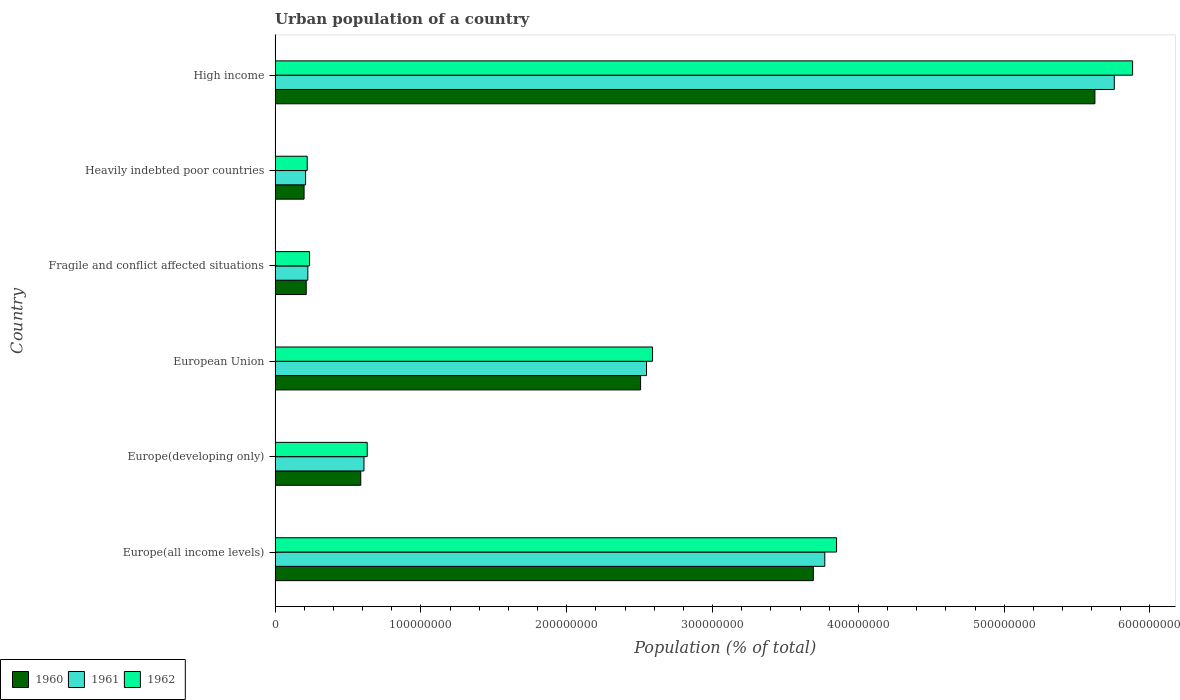Are the number of bars on each tick of the Y-axis equal?
Offer a very short reply. Yes. How many bars are there on the 1st tick from the top?
Offer a very short reply. 3. What is the label of the 1st group of bars from the top?
Your answer should be compact. High income. What is the urban population in 1962 in High income?
Provide a short and direct response. 5.88e+08. Across all countries, what is the maximum urban population in 1960?
Provide a succinct answer. 5.62e+08. Across all countries, what is the minimum urban population in 1961?
Make the answer very short. 2.09e+07. In which country was the urban population in 1962 minimum?
Your response must be concise. Heavily indebted poor countries. What is the total urban population in 1962 in the graph?
Your answer should be very brief. 1.34e+09. What is the difference between the urban population in 1962 in Europe(all income levels) and that in Heavily indebted poor countries?
Make the answer very short. 3.63e+08. What is the difference between the urban population in 1961 in Heavily indebted poor countries and the urban population in 1960 in Fragile and conflict affected situations?
Provide a short and direct response. -4.34e+05. What is the average urban population in 1962 per country?
Your response must be concise. 2.23e+08. What is the difference between the urban population in 1962 and urban population in 1960 in Fragile and conflict affected situations?
Offer a terse response. 2.27e+06. In how many countries, is the urban population in 1961 greater than 580000000 %?
Give a very brief answer. 0. What is the ratio of the urban population in 1960 in Europe(all income levels) to that in Fragile and conflict affected situations?
Ensure brevity in your answer.  17.28. What is the difference between the highest and the second highest urban population in 1960?
Provide a short and direct response. 1.93e+08. What is the difference between the highest and the lowest urban population in 1961?
Provide a succinct answer. 5.55e+08. In how many countries, is the urban population in 1962 greater than the average urban population in 1962 taken over all countries?
Give a very brief answer. 3. What does the 3rd bar from the top in Fragile and conflict affected situations represents?
Provide a succinct answer. 1960. What does the 3rd bar from the bottom in Europe(developing only) represents?
Your answer should be compact. 1962. Is it the case that in every country, the sum of the urban population in 1961 and urban population in 1960 is greater than the urban population in 1962?
Offer a terse response. Yes. How many countries are there in the graph?
Keep it short and to the point. 6. What is the difference between two consecutive major ticks on the X-axis?
Keep it short and to the point. 1.00e+08. Does the graph contain grids?
Offer a terse response. No. How many legend labels are there?
Provide a short and direct response. 3. How are the legend labels stacked?
Offer a very short reply. Horizontal. What is the title of the graph?
Your response must be concise. Urban population of a country. Does "1960" appear as one of the legend labels in the graph?
Offer a very short reply. Yes. What is the label or title of the X-axis?
Your answer should be compact. Population (% of total). What is the label or title of the Y-axis?
Your answer should be compact. Country. What is the Population (% of total) in 1960 in Europe(all income levels)?
Offer a very short reply. 3.69e+08. What is the Population (% of total) in 1961 in Europe(all income levels)?
Give a very brief answer. 3.77e+08. What is the Population (% of total) of 1962 in Europe(all income levels)?
Your answer should be compact. 3.85e+08. What is the Population (% of total) in 1960 in Europe(developing only)?
Your answer should be compact. 5.88e+07. What is the Population (% of total) of 1961 in Europe(developing only)?
Your answer should be compact. 6.10e+07. What is the Population (% of total) in 1962 in Europe(developing only)?
Make the answer very short. 6.32e+07. What is the Population (% of total) of 1960 in European Union?
Your answer should be very brief. 2.51e+08. What is the Population (% of total) of 1961 in European Union?
Ensure brevity in your answer.  2.55e+08. What is the Population (% of total) of 1962 in European Union?
Offer a very short reply. 2.59e+08. What is the Population (% of total) in 1960 in Fragile and conflict affected situations?
Make the answer very short. 2.14e+07. What is the Population (% of total) of 1961 in Fragile and conflict affected situations?
Provide a succinct answer. 2.25e+07. What is the Population (% of total) of 1962 in Fragile and conflict affected situations?
Ensure brevity in your answer.  2.36e+07. What is the Population (% of total) of 1960 in Heavily indebted poor countries?
Offer a very short reply. 1.99e+07. What is the Population (% of total) of 1961 in Heavily indebted poor countries?
Your answer should be compact. 2.09e+07. What is the Population (% of total) in 1962 in Heavily indebted poor countries?
Offer a terse response. 2.20e+07. What is the Population (% of total) of 1960 in High income?
Ensure brevity in your answer.  5.62e+08. What is the Population (% of total) of 1961 in High income?
Ensure brevity in your answer.  5.76e+08. What is the Population (% of total) in 1962 in High income?
Provide a short and direct response. 5.88e+08. Across all countries, what is the maximum Population (% of total) of 1960?
Provide a succinct answer. 5.62e+08. Across all countries, what is the maximum Population (% of total) of 1961?
Provide a short and direct response. 5.76e+08. Across all countries, what is the maximum Population (% of total) of 1962?
Ensure brevity in your answer.  5.88e+08. Across all countries, what is the minimum Population (% of total) of 1960?
Ensure brevity in your answer.  1.99e+07. Across all countries, what is the minimum Population (% of total) of 1961?
Ensure brevity in your answer.  2.09e+07. Across all countries, what is the minimum Population (% of total) in 1962?
Make the answer very short. 2.20e+07. What is the total Population (% of total) in 1960 in the graph?
Offer a very short reply. 1.28e+09. What is the total Population (% of total) of 1961 in the graph?
Give a very brief answer. 1.31e+09. What is the total Population (% of total) in 1962 in the graph?
Your answer should be compact. 1.34e+09. What is the difference between the Population (% of total) in 1960 in Europe(all income levels) and that in Europe(developing only)?
Ensure brevity in your answer.  3.10e+08. What is the difference between the Population (% of total) in 1961 in Europe(all income levels) and that in Europe(developing only)?
Offer a very short reply. 3.16e+08. What is the difference between the Population (% of total) in 1962 in Europe(all income levels) and that in Europe(developing only)?
Your answer should be very brief. 3.22e+08. What is the difference between the Population (% of total) in 1960 in Europe(all income levels) and that in European Union?
Provide a short and direct response. 1.18e+08. What is the difference between the Population (% of total) in 1961 in Europe(all income levels) and that in European Union?
Offer a very short reply. 1.22e+08. What is the difference between the Population (% of total) in 1962 in Europe(all income levels) and that in European Union?
Offer a very short reply. 1.26e+08. What is the difference between the Population (% of total) of 1960 in Europe(all income levels) and that in Fragile and conflict affected situations?
Keep it short and to the point. 3.48e+08. What is the difference between the Population (% of total) of 1961 in Europe(all income levels) and that in Fragile and conflict affected situations?
Your answer should be compact. 3.55e+08. What is the difference between the Population (% of total) of 1962 in Europe(all income levels) and that in Fragile and conflict affected situations?
Offer a very short reply. 3.61e+08. What is the difference between the Population (% of total) in 1960 in Europe(all income levels) and that in Heavily indebted poor countries?
Ensure brevity in your answer.  3.49e+08. What is the difference between the Population (% of total) in 1961 in Europe(all income levels) and that in Heavily indebted poor countries?
Your response must be concise. 3.56e+08. What is the difference between the Population (% of total) in 1962 in Europe(all income levels) and that in Heavily indebted poor countries?
Offer a terse response. 3.63e+08. What is the difference between the Population (% of total) in 1960 in Europe(all income levels) and that in High income?
Your answer should be very brief. -1.93e+08. What is the difference between the Population (% of total) in 1961 in Europe(all income levels) and that in High income?
Provide a short and direct response. -1.99e+08. What is the difference between the Population (% of total) in 1962 in Europe(all income levels) and that in High income?
Offer a very short reply. -2.03e+08. What is the difference between the Population (% of total) in 1960 in Europe(developing only) and that in European Union?
Your answer should be very brief. -1.92e+08. What is the difference between the Population (% of total) in 1961 in Europe(developing only) and that in European Union?
Your response must be concise. -1.94e+08. What is the difference between the Population (% of total) of 1962 in Europe(developing only) and that in European Union?
Your answer should be very brief. -1.96e+08. What is the difference between the Population (% of total) in 1960 in Europe(developing only) and that in Fragile and conflict affected situations?
Your answer should be very brief. 3.74e+07. What is the difference between the Population (% of total) of 1961 in Europe(developing only) and that in Fragile and conflict affected situations?
Ensure brevity in your answer.  3.85e+07. What is the difference between the Population (% of total) of 1962 in Europe(developing only) and that in Fragile and conflict affected situations?
Provide a succinct answer. 3.96e+07. What is the difference between the Population (% of total) in 1960 in Europe(developing only) and that in Heavily indebted poor countries?
Make the answer very short. 3.89e+07. What is the difference between the Population (% of total) in 1961 in Europe(developing only) and that in Heavily indebted poor countries?
Your answer should be compact. 4.00e+07. What is the difference between the Population (% of total) in 1962 in Europe(developing only) and that in Heavily indebted poor countries?
Keep it short and to the point. 4.11e+07. What is the difference between the Population (% of total) in 1960 in Europe(developing only) and that in High income?
Keep it short and to the point. -5.03e+08. What is the difference between the Population (% of total) of 1961 in Europe(developing only) and that in High income?
Offer a very short reply. -5.15e+08. What is the difference between the Population (% of total) of 1962 in Europe(developing only) and that in High income?
Ensure brevity in your answer.  -5.25e+08. What is the difference between the Population (% of total) in 1960 in European Union and that in Fragile and conflict affected situations?
Your response must be concise. 2.29e+08. What is the difference between the Population (% of total) in 1961 in European Union and that in Fragile and conflict affected situations?
Offer a terse response. 2.32e+08. What is the difference between the Population (% of total) in 1962 in European Union and that in Fragile and conflict affected situations?
Ensure brevity in your answer.  2.35e+08. What is the difference between the Population (% of total) of 1960 in European Union and that in Heavily indebted poor countries?
Ensure brevity in your answer.  2.31e+08. What is the difference between the Population (% of total) of 1961 in European Union and that in Heavily indebted poor countries?
Give a very brief answer. 2.34e+08. What is the difference between the Population (% of total) in 1962 in European Union and that in Heavily indebted poor countries?
Your answer should be very brief. 2.37e+08. What is the difference between the Population (% of total) in 1960 in European Union and that in High income?
Your answer should be very brief. -3.12e+08. What is the difference between the Population (% of total) in 1961 in European Union and that in High income?
Provide a succinct answer. -3.21e+08. What is the difference between the Population (% of total) in 1962 in European Union and that in High income?
Offer a very short reply. -3.29e+08. What is the difference between the Population (% of total) of 1960 in Fragile and conflict affected situations and that in Heavily indebted poor countries?
Your answer should be very brief. 1.48e+06. What is the difference between the Population (% of total) in 1961 in Fragile and conflict affected situations and that in Heavily indebted poor countries?
Your response must be concise. 1.53e+06. What is the difference between the Population (% of total) of 1962 in Fragile and conflict affected situations and that in Heavily indebted poor countries?
Ensure brevity in your answer.  1.59e+06. What is the difference between the Population (% of total) of 1960 in Fragile and conflict affected situations and that in High income?
Keep it short and to the point. -5.41e+08. What is the difference between the Population (% of total) in 1961 in Fragile and conflict affected situations and that in High income?
Ensure brevity in your answer.  -5.53e+08. What is the difference between the Population (% of total) of 1962 in Fragile and conflict affected situations and that in High income?
Make the answer very short. -5.64e+08. What is the difference between the Population (% of total) of 1960 in Heavily indebted poor countries and that in High income?
Offer a terse response. -5.42e+08. What is the difference between the Population (% of total) of 1961 in Heavily indebted poor countries and that in High income?
Make the answer very short. -5.55e+08. What is the difference between the Population (% of total) of 1962 in Heavily indebted poor countries and that in High income?
Keep it short and to the point. -5.66e+08. What is the difference between the Population (% of total) in 1960 in Europe(all income levels) and the Population (% of total) in 1961 in Europe(developing only)?
Provide a short and direct response. 3.08e+08. What is the difference between the Population (% of total) of 1960 in Europe(all income levels) and the Population (% of total) of 1962 in Europe(developing only)?
Your answer should be very brief. 3.06e+08. What is the difference between the Population (% of total) in 1961 in Europe(all income levels) and the Population (% of total) in 1962 in Europe(developing only)?
Provide a succinct answer. 3.14e+08. What is the difference between the Population (% of total) in 1960 in Europe(all income levels) and the Population (% of total) in 1961 in European Union?
Your answer should be compact. 1.14e+08. What is the difference between the Population (% of total) in 1960 in Europe(all income levels) and the Population (% of total) in 1962 in European Union?
Keep it short and to the point. 1.10e+08. What is the difference between the Population (% of total) in 1961 in Europe(all income levels) and the Population (% of total) in 1962 in European Union?
Offer a terse response. 1.18e+08. What is the difference between the Population (% of total) in 1960 in Europe(all income levels) and the Population (% of total) in 1961 in Fragile and conflict affected situations?
Make the answer very short. 3.47e+08. What is the difference between the Population (% of total) of 1960 in Europe(all income levels) and the Population (% of total) of 1962 in Fragile and conflict affected situations?
Give a very brief answer. 3.45e+08. What is the difference between the Population (% of total) of 1961 in Europe(all income levels) and the Population (% of total) of 1962 in Fragile and conflict affected situations?
Keep it short and to the point. 3.53e+08. What is the difference between the Population (% of total) of 1960 in Europe(all income levels) and the Population (% of total) of 1961 in Heavily indebted poor countries?
Your response must be concise. 3.48e+08. What is the difference between the Population (% of total) in 1960 in Europe(all income levels) and the Population (% of total) in 1962 in Heavily indebted poor countries?
Ensure brevity in your answer.  3.47e+08. What is the difference between the Population (% of total) of 1961 in Europe(all income levels) and the Population (% of total) of 1962 in Heavily indebted poor countries?
Your answer should be compact. 3.55e+08. What is the difference between the Population (% of total) of 1960 in Europe(all income levels) and the Population (% of total) of 1961 in High income?
Your answer should be very brief. -2.06e+08. What is the difference between the Population (% of total) in 1960 in Europe(all income levels) and the Population (% of total) in 1962 in High income?
Offer a very short reply. -2.19e+08. What is the difference between the Population (% of total) of 1961 in Europe(all income levels) and the Population (% of total) of 1962 in High income?
Ensure brevity in your answer.  -2.11e+08. What is the difference between the Population (% of total) of 1960 in Europe(developing only) and the Population (% of total) of 1961 in European Union?
Offer a terse response. -1.96e+08. What is the difference between the Population (% of total) of 1960 in Europe(developing only) and the Population (% of total) of 1962 in European Union?
Your answer should be compact. -2.00e+08. What is the difference between the Population (% of total) of 1961 in Europe(developing only) and the Population (% of total) of 1962 in European Union?
Your answer should be very brief. -1.98e+08. What is the difference between the Population (% of total) in 1960 in Europe(developing only) and the Population (% of total) in 1961 in Fragile and conflict affected situations?
Give a very brief answer. 3.63e+07. What is the difference between the Population (% of total) of 1960 in Europe(developing only) and the Population (% of total) of 1962 in Fragile and conflict affected situations?
Keep it short and to the point. 3.51e+07. What is the difference between the Population (% of total) of 1961 in Europe(developing only) and the Population (% of total) of 1962 in Fragile and conflict affected situations?
Ensure brevity in your answer.  3.73e+07. What is the difference between the Population (% of total) in 1960 in Europe(developing only) and the Population (% of total) in 1961 in Heavily indebted poor countries?
Give a very brief answer. 3.78e+07. What is the difference between the Population (% of total) of 1960 in Europe(developing only) and the Population (% of total) of 1962 in Heavily indebted poor countries?
Your answer should be very brief. 3.67e+07. What is the difference between the Population (% of total) in 1961 in Europe(developing only) and the Population (% of total) in 1962 in Heavily indebted poor countries?
Provide a short and direct response. 3.89e+07. What is the difference between the Population (% of total) of 1960 in Europe(developing only) and the Population (% of total) of 1961 in High income?
Your answer should be compact. -5.17e+08. What is the difference between the Population (% of total) of 1960 in Europe(developing only) and the Population (% of total) of 1962 in High income?
Make the answer very short. -5.29e+08. What is the difference between the Population (% of total) in 1961 in Europe(developing only) and the Population (% of total) in 1962 in High income?
Give a very brief answer. -5.27e+08. What is the difference between the Population (% of total) of 1960 in European Union and the Population (% of total) of 1961 in Fragile and conflict affected situations?
Provide a short and direct response. 2.28e+08. What is the difference between the Population (% of total) of 1960 in European Union and the Population (% of total) of 1962 in Fragile and conflict affected situations?
Make the answer very short. 2.27e+08. What is the difference between the Population (% of total) in 1961 in European Union and the Population (% of total) in 1962 in Fragile and conflict affected situations?
Your answer should be compact. 2.31e+08. What is the difference between the Population (% of total) of 1960 in European Union and the Population (% of total) of 1961 in Heavily indebted poor countries?
Your answer should be very brief. 2.30e+08. What is the difference between the Population (% of total) in 1960 in European Union and the Population (% of total) in 1962 in Heavily indebted poor countries?
Keep it short and to the point. 2.29e+08. What is the difference between the Population (% of total) of 1961 in European Union and the Population (% of total) of 1962 in Heavily indebted poor countries?
Offer a terse response. 2.33e+08. What is the difference between the Population (% of total) in 1960 in European Union and the Population (% of total) in 1961 in High income?
Your response must be concise. -3.25e+08. What is the difference between the Population (% of total) in 1960 in European Union and the Population (% of total) in 1962 in High income?
Provide a short and direct response. -3.37e+08. What is the difference between the Population (% of total) of 1961 in European Union and the Population (% of total) of 1962 in High income?
Keep it short and to the point. -3.33e+08. What is the difference between the Population (% of total) of 1960 in Fragile and conflict affected situations and the Population (% of total) of 1961 in Heavily indebted poor countries?
Make the answer very short. 4.34e+05. What is the difference between the Population (% of total) of 1960 in Fragile and conflict affected situations and the Population (% of total) of 1962 in Heavily indebted poor countries?
Keep it short and to the point. -6.80e+05. What is the difference between the Population (% of total) of 1961 in Fragile and conflict affected situations and the Population (% of total) of 1962 in Heavily indebted poor countries?
Ensure brevity in your answer.  4.21e+05. What is the difference between the Population (% of total) in 1960 in Fragile and conflict affected situations and the Population (% of total) in 1961 in High income?
Your response must be concise. -5.54e+08. What is the difference between the Population (% of total) in 1960 in Fragile and conflict affected situations and the Population (% of total) in 1962 in High income?
Provide a succinct answer. -5.67e+08. What is the difference between the Population (% of total) in 1961 in Fragile and conflict affected situations and the Population (% of total) in 1962 in High income?
Offer a very short reply. -5.66e+08. What is the difference between the Population (% of total) in 1960 in Heavily indebted poor countries and the Population (% of total) in 1961 in High income?
Make the answer very short. -5.56e+08. What is the difference between the Population (% of total) in 1960 in Heavily indebted poor countries and the Population (% of total) in 1962 in High income?
Provide a short and direct response. -5.68e+08. What is the difference between the Population (% of total) of 1961 in Heavily indebted poor countries and the Population (% of total) of 1962 in High income?
Keep it short and to the point. -5.67e+08. What is the average Population (% of total) of 1960 per country?
Offer a terse response. 2.14e+08. What is the average Population (% of total) in 1961 per country?
Offer a terse response. 2.19e+08. What is the average Population (% of total) in 1962 per country?
Keep it short and to the point. 2.23e+08. What is the difference between the Population (% of total) in 1960 and Population (% of total) in 1961 in Europe(all income levels)?
Your response must be concise. -7.86e+06. What is the difference between the Population (% of total) of 1960 and Population (% of total) of 1962 in Europe(all income levels)?
Offer a very short reply. -1.59e+07. What is the difference between the Population (% of total) in 1961 and Population (% of total) in 1962 in Europe(all income levels)?
Your response must be concise. -8.07e+06. What is the difference between the Population (% of total) in 1960 and Population (% of total) in 1961 in Europe(developing only)?
Give a very brief answer. -2.20e+06. What is the difference between the Population (% of total) of 1960 and Population (% of total) of 1962 in Europe(developing only)?
Give a very brief answer. -4.43e+06. What is the difference between the Population (% of total) of 1961 and Population (% of total) of 1962 in Europe(developing only)?
Make the answer very short. -2.23e+06. What is the difference between the Population (% of total) in 1960 and Population (% of total) in 1961 in European Union?
Your response must be concise. -4.05e+06. What is the difference between the Population (% of total) of 1960 and Population (% of total) of 1962 in European Union?
Give a very brief answer. -8.20e+06. What is the difference between the Population (% of total) in 1961 and Population (% of total) in 1962 in European Union?
Ensure brevity in your answer.  -4.14e+06. What is the difference between the Population (% of total) of 1960 and Population (% of total) of 1961 in Fragile and conflict affected situations?
Your answer should be compact. -1.10e+06. What is the difference between the Population (% of total) of 1960 and Population (% of total) of 1962 in Fragile and conflict affected situations?
Ensure brevity in your answer.  -2.27e+06. What is the difference between the Population (% of total) in 1961 and Population (% of total) in 1962 in Fragile and conflict affected situations?
Your response must be concise. -1.17e+06. What is the difference between the Population (% of total) in 1960 and Population (% of total) in 1961 in Heavily indebted poor countries?
Offer a terse response. -1.05e+06. What is the difference between the Population (% of total) of 1960 and Population (% of total) of 1962 in Heavily indebted poor countries?
Ensure brevity in your answer.  -2.16e+06. What is the difference between the Population (% of total) of 1961 and Population (% of total) of 1962 in Heavily indebted poor countries?
Make the answer very short. -1.11e+06. What is the difference between the Population (% of total) in 1960 and Population (% of total) in 1961 in High income?
Provide a short and direct response. -1.33e+07. What is the difference between the Population (% of total) of 1960 and Population (% of total) of 1962 in High income?
Give a very brief answer. -2.59e+07. What is the difference between the Population (% of total) in 1961 and Population (% of total) in 1962 in High income?
Provide a short and direct response. -1.26e+07. What is the ratio of the Population (% of total) in 1960 in Europe(all income levels) to that in Europe(developing only)?
Provide a short and direct response. 6.28. What is the ratio of the Population (% of total) of 1961 in Europe(all income levels) to that in Europe(developing only)?
Offer a very short reply. 6.18. What is the ratio of the Population (% of total) in 1962 in Europe(all income levels) to that in Europe(developing only)?
Make the answer very short. 6.09. What is the ratio of the Population (% of total) in 1960 in Europe(all income levels) to that in European Union?
Make the answer very short. 1.47. What is the ratio of the Population (% of total) in 1961 in Europe(all income levels) to that in European Union?
Offer a terse response. 1.48. What is the ratio of the Population (% of total) of 1962 in Europe(all income levels) to that in European Union?
Your answer should be very brief. 1.49. What is the ratio of the Population (% of total) in 1960 in Europe(all income levels) to that in Fragile and conflict affected situations?
Keep it short and to the point. 17.28. What is the ratio of the Population (% of total) of 1961 in Europe(all income levels) to that in Fragile and conflict affected situations?
Offer a terse response. 16.78. What is the ratio of the Population (% of total) in 1962 in Europe(all income levels) to that in Fragile and conflict affected situations?
Ensure brevity in your answer.  16.29. What is the ratio of the Population (% of total) in 1960 in Europe(all income levels) to that in Heavily indebted poor countries?
Make the answer very short. 18.57. What is the ratio of the Population (% of total) in 1961 in Europe(all income levels) to that in Heavily indebted poor countries?
Give a very brief answer. 18.01. What is the ratio of the Population (% of total) of 1962 in Europe(all income levels) to that in Heavily indebted poor countries?
Keep it short and to the point. 17.47. What is the ratio of the Population (% of total) of 1960 in Europe(all income levels) to that in High income?
Your answer should be very brief. 0.66. What is the ratio of the Population (% of total) of 1961 in Europe(all income levels) to that in High income?
Provide a succinct answer. 0.66. What is the ratio of the Population (% of total) of 1962 in Europe(all income levels) to that in High income?
Offer a terse response. 0.65. What is the ratio of the Population (% of total) of 1960 in Europe(developing only) to that in European Union?
Offer a terse response. 0.23. What is the ratio of the Population (% of total) in 1961 in Europe(developing only) to that in European Union?
Offer a terse response. 0.24. What is the ratio of the Population (% of total) of 1962 in Europe(developing only) to that in European Union?
Your answer should be very brief. 0.24. What is the ratio of the Population (% of total) in 1960 in Europe(developing only) to that in Fragile and conflict affected situations?
Give a very brief answer. 2.75. What is the ratio of the Population (% of total) of 1961 in Europe(developing only) to that in Fragile and conflict affected situations?
Offer a terse response. 2.71. What is the ratio of the Population (% of total) in 1962 in Europe(developing only) to that in Fragile and conflict affected situations?
Give a very brief answer. 2.67. What is the ratio of the Population (% of total) of 1960 in Europe(developing only) to that in Heavily indebted poor countries?
Provide a short and direct response. 2.96. What is the ratio of the Population (% of total) in 1961 in Europe(developing only) to that in Heavily indebted poor countries?
Your answer should be very brief. 2.91. What is the ratio of the Population (% of total) of 1962 in Europe(developing only) to that in Heavily indebted poor countries?
Offer a very short reply. 2.87. What is the ratio of the Population (% of total) of 1960 in Europe(developing only) to that in High income?
Make the answer very short. 0.1. What is the ratio of the Population (% of total) in 1961 in Europe(developing only) to that in High income?
Your answer should be compact. 0.11. What is the ratio of the Population (% of total) of 1962 in Europe(developing only) to that in High income?
Give a very brief answer. 0.11. What is the ratio of the Population (% of total) in 1960 in European Union to that in Fragile and conflict affected situations?
Offer a terse response. 11.73. What is the ratio of the Population (% of total) of 1961 in European Union to that in Fragile and conflict affected situations?
Make the answer very short. 11.34. What is the ratio of the Population (% of total) in 1962 in European Union to that in Fragile and conflict affected situations?
Keep it short and to the point. 10.95. What is the ratio of the Population (% of total) in 1960 in European Union to that in Heavily indebted poor countries?
Keep it short and to the point. 12.61. What is the ratio of the Population (% of total) in 1961 in European Union to that in Heavily indebted poor countries?
Ensure brevity in your answer.  12.17. What is the ratio of the Population (% of total) of 1962 in European Union to that in Heavily indebted poor countries?
Your answer should be compact. 11.74. What is the ratio of the Population (% of total) of 1960 in European Union to that in High income?
Keep it short and to the point. 0.45. What is the ratio of the Population (% of total) of 1961 in European Union to that in High income?
Offer a very short reply. 0.44. What is the ratio of the Population (% of total) of 1962 in European Union to that in High income?
Keep it short and to the point. 0.44. What is the ratio of the Population (% of total) in 1960 in Fragile and conflict affected situations to that in Heavily indebted poor countries?
Your response must be concise. 1.07. What is the ratio of the Population (% of total) of 1961 in Fragile and conflict affected situations to that in Heavily indebted poor countries?
Ensure brevity in your answer.  1.07. What is the ratio of the Population (% of total) in 1962 in Fragile and conflict affected situations to that in Heavily indebted poor countries?
Ensure brevity in your answer.  1.07. What is the ratio of the Population (% of total) of 1960 in Fragile and conflict affected situations to that in High income?
Offer a terse response. 0.04. What is the ratio of the Population (% of total) of 1961 in Fragile and conflict affected situations to that in High income?
Give a very brief answer. 0.04. What is the ratio of the Population (% of total) of 1962 in Fragile and conflict affected situations to that in High income?
Ensure brevity in your answer.  0.04. What is the ratio of the Population (% of total) in 1960 in Heavily indebted poor countries to that in High income?
Your answer should be compact. 0.04. What is the ratio of the Population (% of total) of 1961 in Heavily indebted poor countries to that in High income?
Provide a succinct answer. 0.04. What is the ratio of the Population (% of total) in 1962 in Heavily indebted poor countries to that in High income?
Give a very brief answer. 0.04. What is the difference between the highest and the second highest Population (% of total) of 1960?
Your answer should be compact. 1.93e+08. What is the difference between the highest and the second highest Population (% of total) of 1961?
Ensure brevity in your answer.  1.99e+08. What is the difference between the highest and the second highest Population (% of total) of 1962?
Provide a succinct answer. 2.03e+08. What is the difference between the highest and the lowest Population (% of total) in 1960?
Give a very brief answer. 5.42e+08. What is the difference between the highest and the lowest Population (% of total) of 1961?
Make the answer very short. 5.55e+08. What is the difference between the highest and the lowest Population (% of total) in 1962?
Make the answer very short. 5.66e+08. 